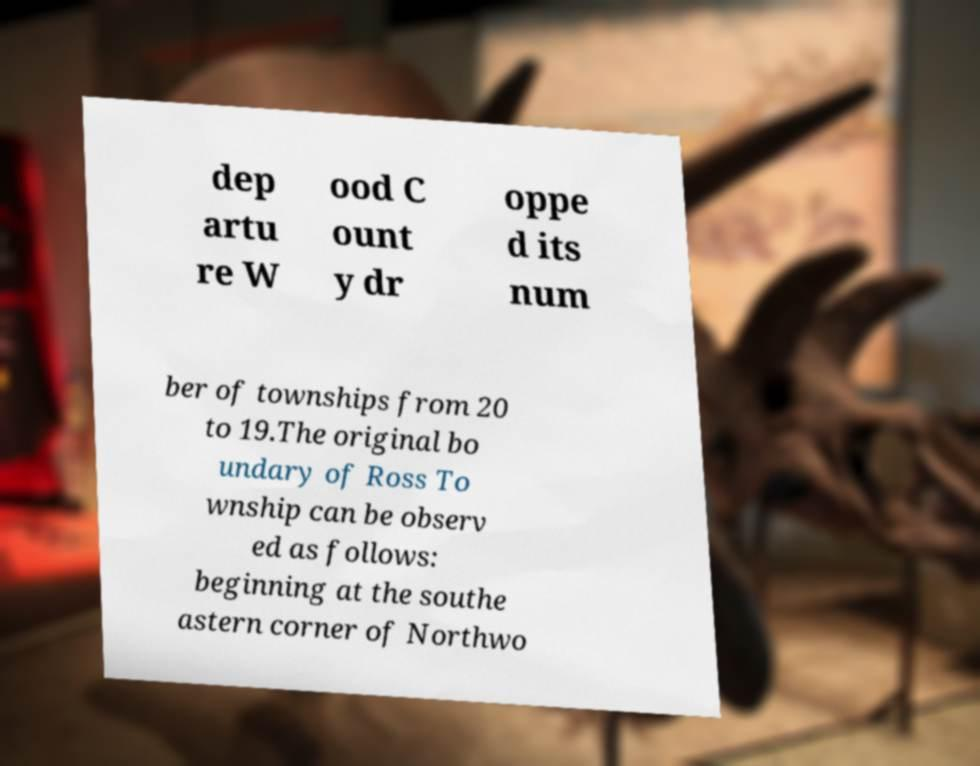Can you read and provide the text displayed in the image?This photo seems to have some interesting text. Can you extract and type it out for me? dep artu re W ood C ount y dr oppe d its num ber of townships from 20 to 19.The original bo undary of Ross To wnship can be observ ed as follows: beginning at the southe astern corner of Northwo 